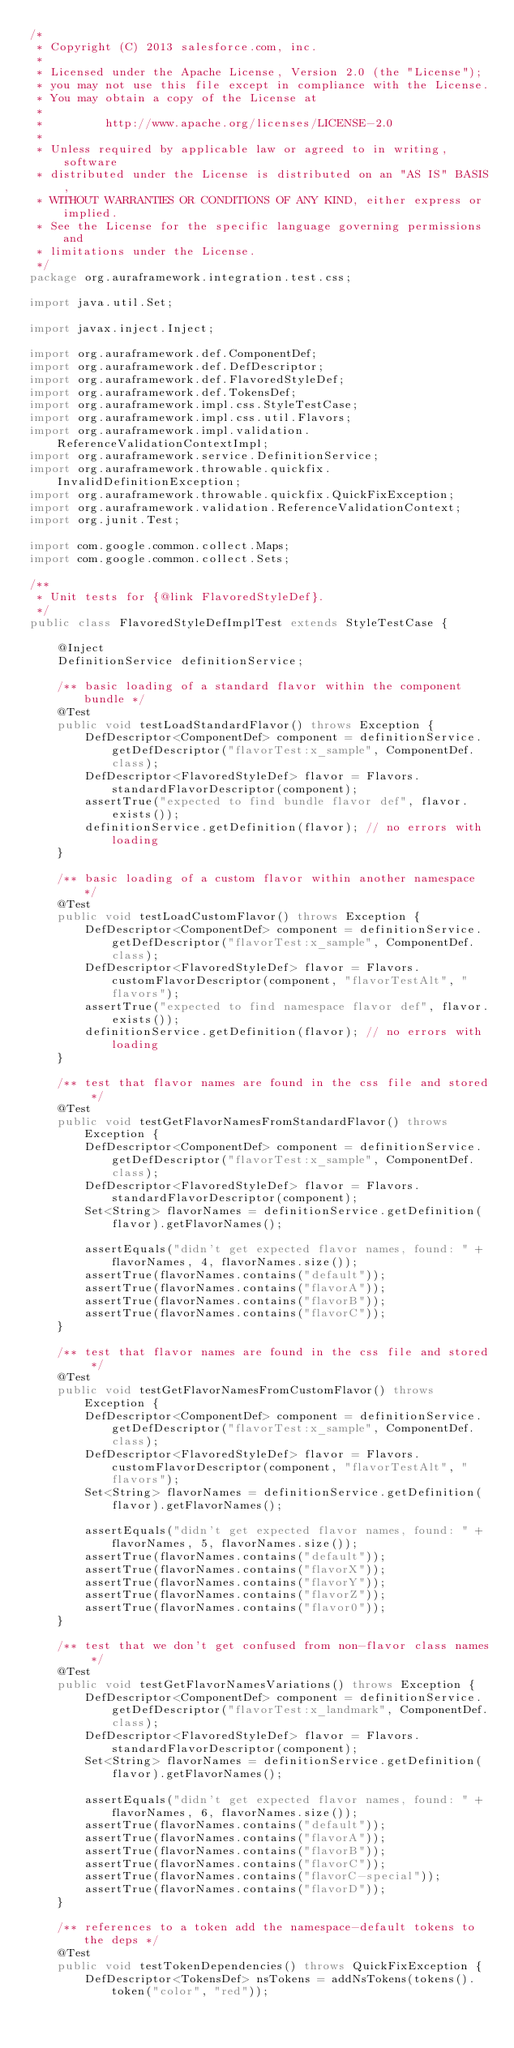<code> <loc_0><loc_0><loc_500><loc_500><_Java_>/*
 * Copyright (C) 2013 salesforce.com, inc.
 *
 * Licensed under the Apache License, Version 2.0 (the "License");
 * you may not use this file except in compliance with the License.
 * You may obtain a copy of the License at
 *
 *         http://www.apache.org/licenses/LICENSE-2.0
 *
 * Unless required by applicable law or agreed to in writing, software
 * distributed under the License is distributed on an "AS IS" BASIS,
 * WITHOUT WARRANTIES OR CONDITIONS OF ANY KIND, either express or implied.
 * See the License for the specific language governing permissions and
 * limitations under the License.
 */
package org.auraframework.integration.test.css;

import java.util.Set;

import javax.inject.Inject;

import org.auraframework.def.ComponentDef;
import org.auraframework.def.DefDescriptor;
import org.auraframework.def.FlavoredStyleDef;
import org.auraframework.def.TokensDef;
import org.auraframework.impl.css.StyleTestCase;
import org.auraframework.impl.css.util.Flavors;
import org.auraframework.impl.validation.ReferenceValidationContextImpl;
import org.auraframework.service.DefinitionService;
import org.auraframework.throwable.quickfix.InvalidDefinitionException;
import org.auraframework.throwable.quickfix.QuickFixException;
import org.auraframework.validation.ReferenceValidationContext;
import org.junit.Test;

import com.google.common.collect.Maps;
import com.google.common.collect.Sets;

/**
 * Unit tests for {@link FlavoredStyleDef}.
 */
public class FlavoredStyleDefImplTest extends StyleTestCase {

    @Inject
    DefinitionService definitionService;

    /** basic loading of a standard flavor within the component bundle */
    @Test
    public void testLoadStandardFlavor() throws Exception {
        DefDescriptor<ComponentDef> component = definitionService.getDefDescriptor("flavorTest:x_sample", ComponentDef.class);
        DefDescriptor<FlavoredStyleDef> flavor = Flavors.standardFlavorDescriptor(component);
        assertTrue("expected to find bundle flavor def", flavor.exists());
        definitionService.getDefinition(flavor); // no errors with loading
    }

    /** basic loading of a custom flavor within another namespace */
    @Test
    public void testLoadCustomFlavor() throws Exception {
        DefDescriptor<ComponentDef> component = definitionService.getDefDescriptor("flavorTest:x_sample", ComponentDef.class);
        DefDescriptor<FlavoredStyleDef> flavor = Flavors.customFlavorDescriptor(component, "flavorTestAlt", "flavors");
        assertTrue("expected to find namespace flavor def", flavor.exists());
        definitionService.getDefinition(flavor); // no errors with loading
    }

    /** test that flavor names are found in the css file and stored */
    @Test
    public void testGetFlavorNamesFromStandardFlavor() throws Exception {
        DefDescriptor<ComponentDef> component = definitionService.getDefDescriptor("flavorTest:x_sample", ComponentDef.class);
        DefDescriptor<FlavoredStyleDef> flavor = Flavors.standardFlavorDescriptor(component);
        Set<String> flavorNames = definitionService.getDefinition(flavor).getFlavorNames();

        assertEquals("didn't get expected flavor names, found: " + flavorNames, 4, flavorNames.size());
        assertTrue(flavorNames.contains("default"));
        assertTrue(flavorNames.contains("flavorA"));
        assertTrue(flavorNames.contains("flavorB"));
        assertTrue(flavorNames.contains("flavorC"));
    }

    /** test that flavor names are found in the css file and stored */
    @Test
    public void testGetFlavorNamesFromCustomFlavor() throws Exception {
        DefDescriptor<ComponentDef> component = definitionService.getDefDescriptor("flavorTest:x_sample", ComponentDef.class);
        DefDescriptor<FlavoredStyleDef> flavor = Flavors.customFlavorDescriptor(component, "flavorTestAlt", "flavors");
        Set<String> flavorNames = definitionService.getDefinition(flavor).getFlavorNames();

        assertEquals("didn't get expected flavor names, found: " + flavorNames, 5, flavorNames.size());
        assertTrue(flavorNames.contains("default"));
        assertTrue(flavorNames.contains("flavorX"));
        assertTrue(flavorNames.contains("flavorY"));
        assertTrue(flavorNames.contains("flavorZ"));
        assertTrue(flavorNames.contains("flavor0"));
    }

    /** test that we don't get confused from non-flavor class names */
    @Test
    public void testGetFlavorNamesVariations() throws Exception {
        DefDescriptor<ComponentDef> component = definitionService.getDefDescriptor("flavorTest:x_landmark", ComponentDef.class);
        DefDescriptor<FlavoredStyleDef> flavor = Flavors.standardFlavorDescriptor(component);
        Set<String> flavorNames = definitionService.getDefinition(flavor).getFlavorNames();

        assertEquals("didn't get expected flavor names, found: " + flavorNames, 6, flavorNames.size());
        assertTrue(flavorNames.contains("default"));
        assertTrue(flavorNames.contains("flavorA"));
        assertTrue(flavorNames.contains("flavorB"));
        assertTrue(flavorNames.contains("flavorC"));
        assertTrue(flavorNames.contains("flavorC-special"));
        assertTrue(flavorNames.contains("flavorD"));
    }

    /** references to a token add the namespace-default tokens to the deps */
    @Test
    public void testTokenDependencies() throws QuickFixException {
        DefDescriptor<TokensDef> nsTokens = addNsTokens(tokens().token("color", "red"));</code> 